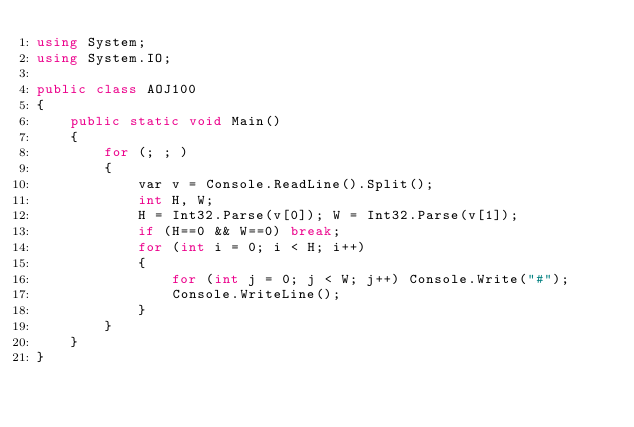<code> <loc_0><loc_0><loc_500><loc_500><_C#_>using System;
using System.IO;

public class AOJ100
{
    public static void Main()
    {
        for (; ; )
        {
            var v = Console.ReadLine().Split();
            int H, W;
            H = Int32.Parse(v[0]); W = Int32.Parse(v[1]);
            if (H==0 && W==0) break;
            for (int i = 0; i < H; i++)
            {
                for (int j = 0; j < W; j++) Console.Write("#");
                Console.WriteLine();
            }
        }
    }
}</code> 